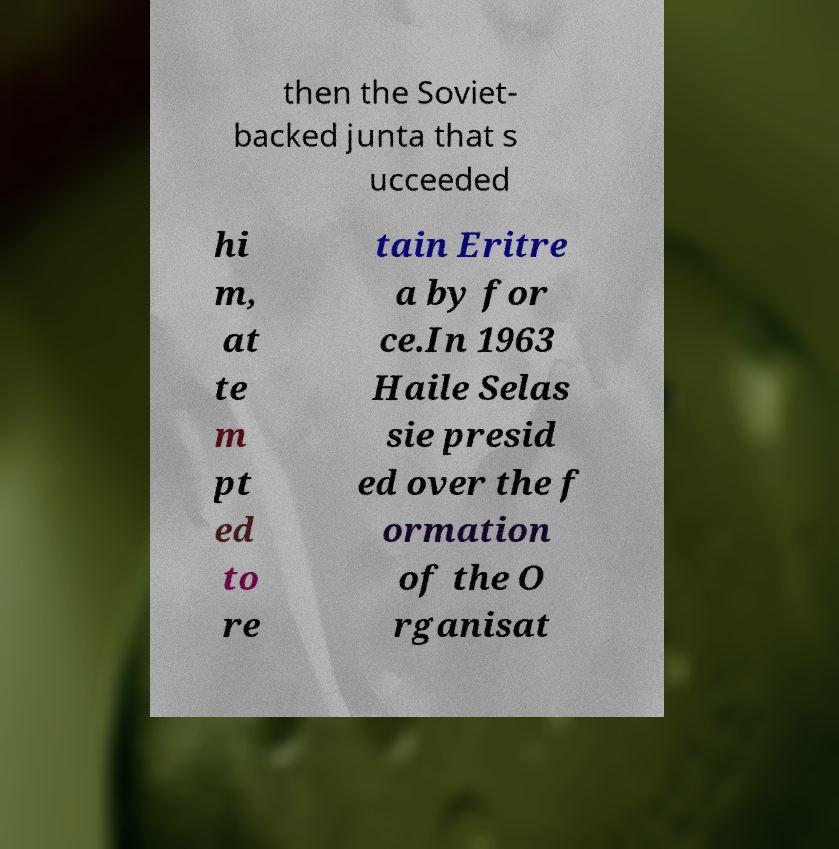What messages or text are displayed in this image? I need them in a readable, typed format. then the Soviet- backed junta that s ucceeded hi m, at te m pt ed to re tain Eritre a by for ce.In 1963 Haile Selas sie presid ed over the f ormation of the O rganisat 